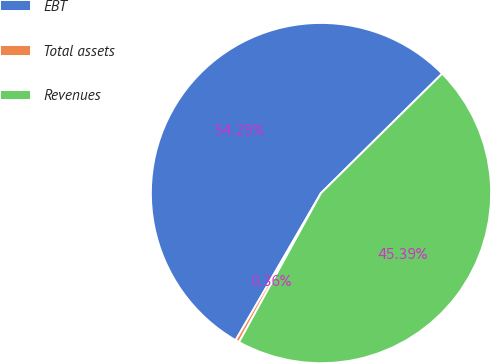Convert chart. <chart><loc_0><loc_0><loc_500><loc_500><pie_chart><fcel>EBT<fcel>Total assets<fcel>Revenues<nl><fcel>54.24%<fcel>0.36%<fcel>45.39%<nl></chart> 